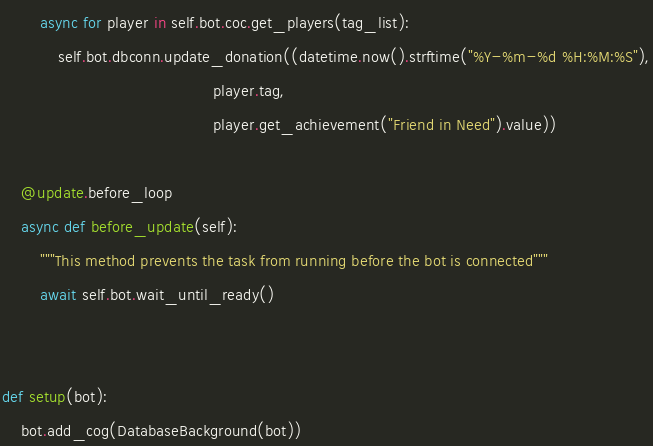<code> <loc_0><loc_0><loc_500><loc_500><_Python_>        async for player in self.bot.coc.get_players(tag_list):
            self.bot.dbconn.update_donation((datetime.now().strftime("%Y-%m-%d %H:%M:%S"),
                                             player.tag,
                                             player.get_achievement("Friend in Need").value))

    @update.before_loop
    async def before_update(self):
        """This method prevents the task from running before the bot is connected"""
        await self.bot.wait_until_ready()


def setup(bot):
    bot.add_cog(DatabaseBackground(bot))
</code> 